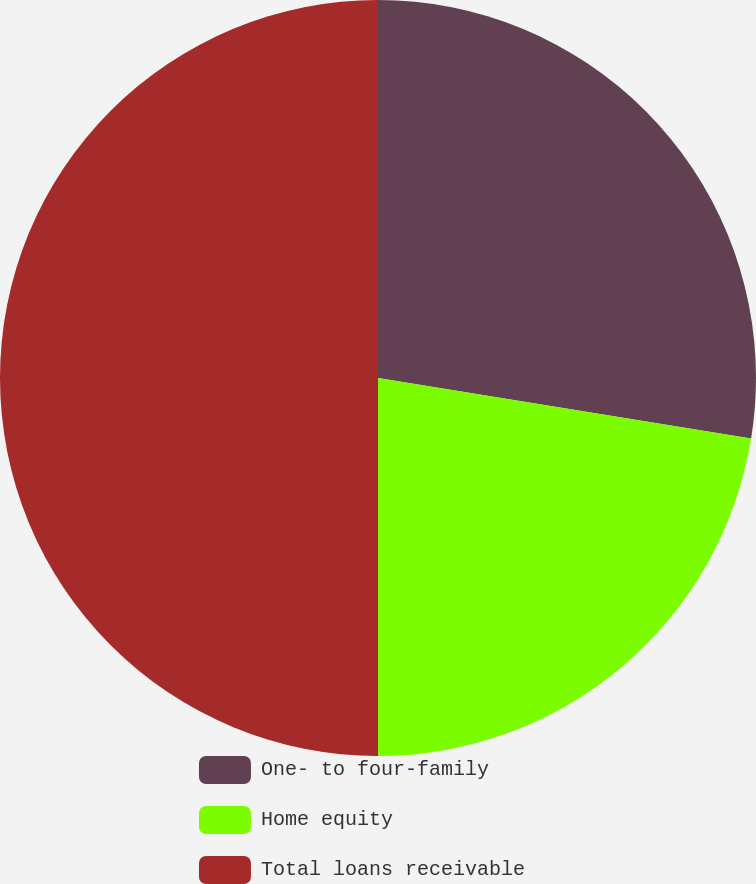<chart> <loc_0><loc_0><loc_500><loc_500><pie_chart><fcel>One- to four-family<fcel>Home equity<fcel>Total loans receivable<nl><fcel>27.56%<fcel>22.44%<fcel>50.0%<nl></chart> 